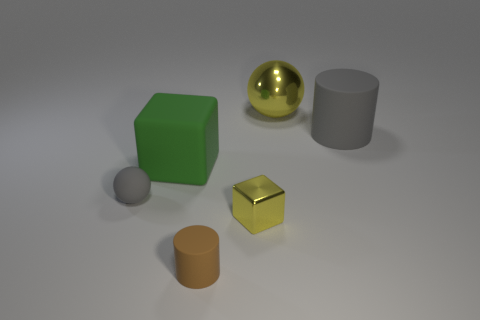Add 2 tiny blue matte cylinders. How many objects exist? 8 Subtract all balls. How many objects are left? 4 Subtract all cyan blocks. Subtract all blue cylinders. How many blocks are left? 2 Subtract all gray cylinders. How many gray balls are left? 1 Subtract all large brown matte objects. Subtract all large spheres. How many objects are left? 5 Add 4 brown cylinders. How many brown cylinders are left? 5 Add 3 small red matte cubes. How many small red matte cubes exist? 3 Subtract 1 brown cylinders. How many objects are left? 5 Subtract 1 balls. How many balls are left? 1 